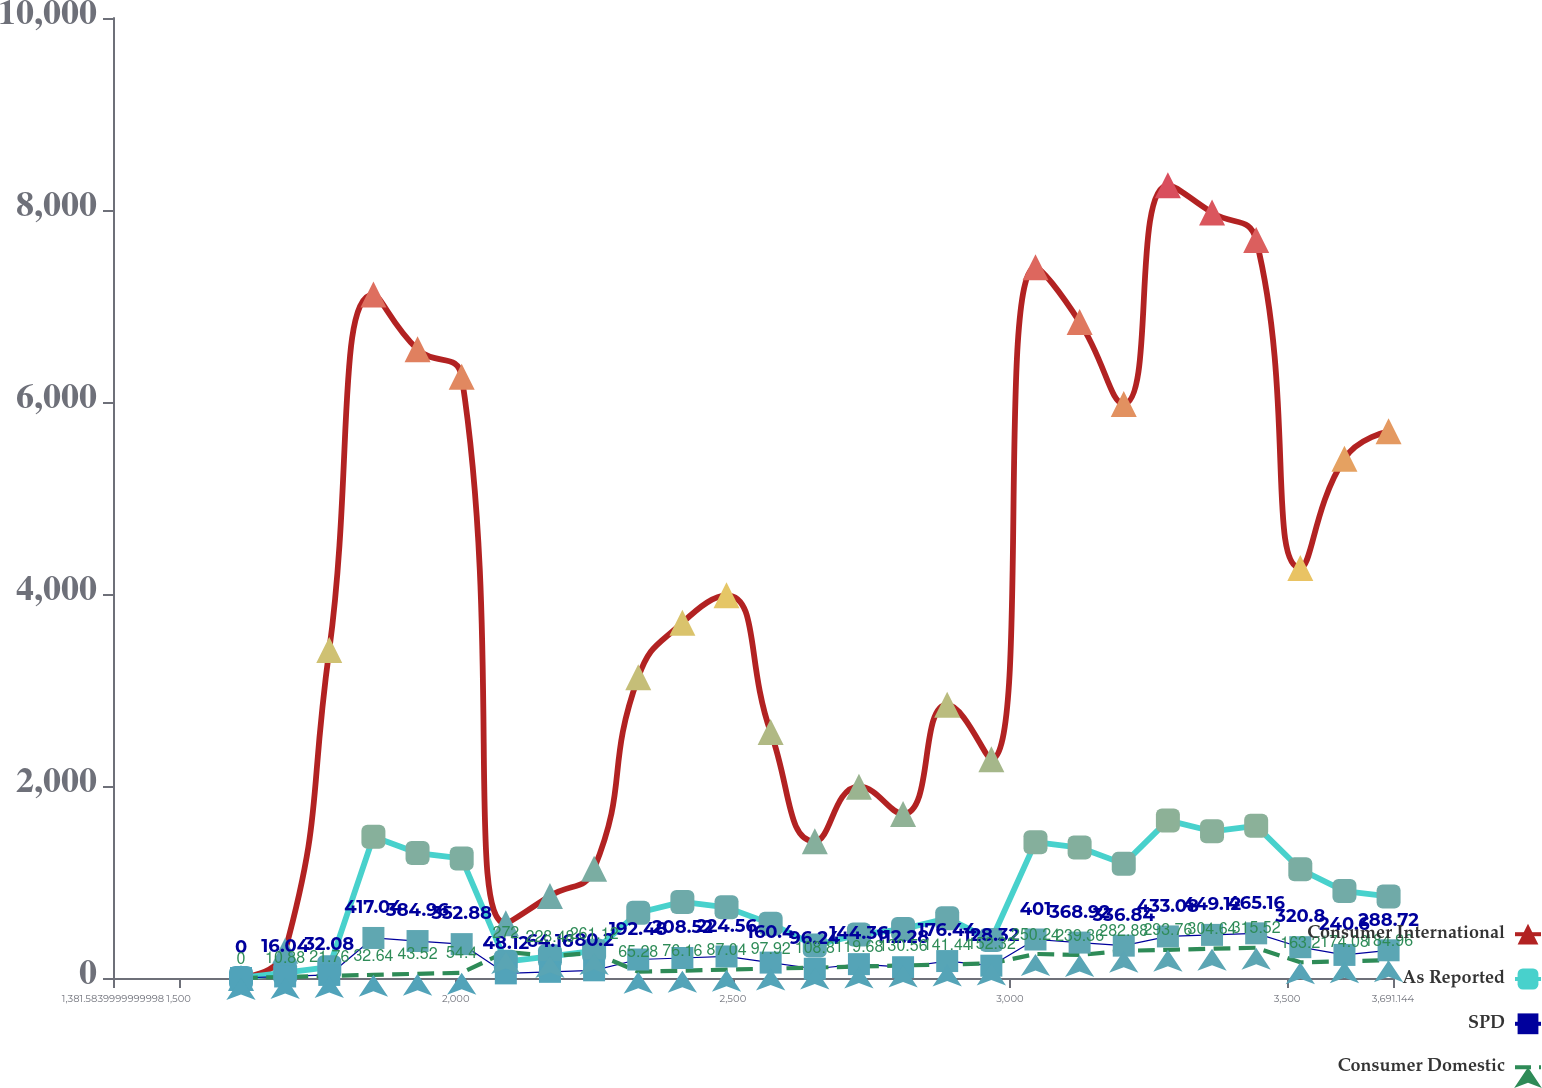<chart> <loc_0><loc_0><loc_500><loc_500><line_chart><ecel><fcel>Consumer International<fcel>As Reported<fcel>SPD<fcel>Consumer Domestic<nl><fcel>1612.54<fcel>0<fcel>0<fcel>0<fcel>0<nl><fcel>1692.18<fcel>284.74<fcel>56.61<fcel>16.04<fcel>10.88<nl><fcel>1771.82<fcel>3416.88<fcel>113.22<fcel>32.08<fcel>21.76<nl><fcel>1851.46<fcel>7118.5<fcel>1471.86<fcel>417.04<fcel>32.64<nl><fcel>1931.1<fcel>6549.02<fcel>1302.03<fcel>384.96<fcel>43.52<nl><fcel>2010.74<fcel>6264.28<fcel>1245.42<fcel>352.88<fcel>54.4<nl><fcel>2090.38<fcel>569.48<fcel>169.83<fcel>48.12<fcel>272<nl><fcel>2170.02<fcel>854.22<fcel>226.44<fcel>64.16<fcel>228.48<nl><fcel>2249.66<fcel>1138.96<fcel>283.05<fcel>80.2<fcel>261.12<nl><fcel>2329.3<fcel>3132.14<fcel>679.32<fcel>192.48<fcel>65.28<nl><fcel>2408.94<fcel>3701.62<fcel>792.54<fcel>208.52<fcel>76.16<nl><fcel>2488.58<fcel>3986.36<fcel>735.93<fcel>224.56<fcel>87.04<nl><fcel>2568.22<fcel>2562.66<fcel>566.1<fcel>160.4<fcel>97.92<nl><fcel>2647.86<fcel>1423.7<fcel>339.66<fcel>96.24<fcel>108.8<nl><fcel>2727.5<fcel>1993.18<fcel>452.88<fcel>144.36<fcel>119.68<nl><fcel>2807.14<fcel>1708.44<fcel>509.49<fcel>112.28<fcel>130.56<nl><fcel>2886.78<fcel>2847.4<fcel>622.71<fcel>176.44<fcel>141.44<nl><fcel>2966.42<fcel>2277.92<fcel>396.27<fcel>128.32<fcel>152.32<nl><fcel>3046.06<fcel>7403.24<fcel>1415.25<fcel>401<fcel>250.24<nl><fcel>3125.7<fcel>6833.76<fcel>1358.64<fcel>368.92<fcel>239.36<nl><fcel>3205.34<fcel>5979.54<fcel>1188.81<fcel>336.84<fcel>282.88<nl><fcel>3284.98<fcel>8257.46<fcel>1641.69<fcel>433.08<fcel>293.76<nl><fcel>3364.62<fcel>7972.72<fcel>1528.47<fcel>449.12<fcel>304.64<nl><fcel>3444.26<fcel>7687.98<fcel>1585.08<fcel>465.16<fcel>315.52<nl><fcel>3523.9<fcel>4271.1<fcel>1132.2<fcel>320.8<fcel>163.2<nl><fcel>3603.54<fcel>5410.06<fcel>905.76<fcel>240.6<fcel>174.08<nl><fcel>3683.18<fcel>5694.8<fcel>849.15<fcel>288.72<fcel>184.96<nl><fcel>3762.82<fcel>4840.58<fcel>1018.98<fcel>304.76<fcel>195.84<nl><fcel>3842.46<fcel>5125.32<fcel>1075.59<fcel>256.64<fcel>206.72<nl><fcel>3922.1<fcel>4555.84<fcel>962.37<fcel>272.68<fcel>217.6<nl></chart> 